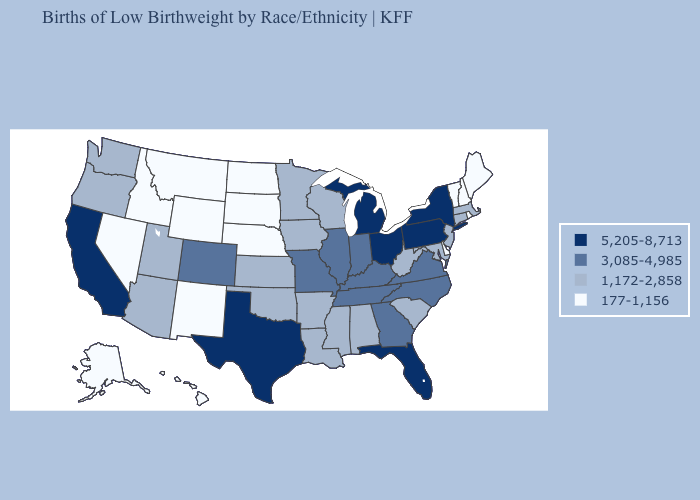Which states hav the highest value in the South?
Answer briefly. Florida, Texas. Among the states that border Wisconsin , does Minnesota have the lowest value?
Quick response, please. Yes. Does the first symbol in the legend represent the smallest category?
Keep it brief. No. Among the states that border Idaho , which have the lowest value?
Quick response, please. Montana, Nevada, Wyoming. Does the first symbol in the legend represent the smallest category?
Give a very brief answer. No. What is the value of Maine?
Keep it brief. 177-1,156. Which states have the highest value in the USA?
Short answer required. California, Florida, Michigan, New York, Ohio, Pennsylvania, Texas. Among the states that border Illinois , does Wisconsin have the highest value?
Write a very short answer. No. What is the value of Tennessee?
Be succinct. 3,085-4,985. Does the map have missing data?
Write a very short answer. No. Name the states that have a value in the range 177-1,156?
Give a very brief answer. Alaska, Delaware, Hawaii, Idaho, Maine, Montana, Nebraska, Nevada, New Hampshire, New Mexico, North Dakota, Rhode Island, South Dakota, Vermont, Wyoming. Does the map have missing data?
Give a very brief answer. No. Name the states that have a value in the range 5,205-8,713?
Be succinct. California, Florida, Michigan, New York, Ohio, Pennsylvania, Texas. Name the states that have a value in the range 3,085-4,985?
Give a very brief answer. Colorado, Georgia, Illinois, Indiana, Kentucky, Missouri, North Carolina, Tennessee, Virginia. 